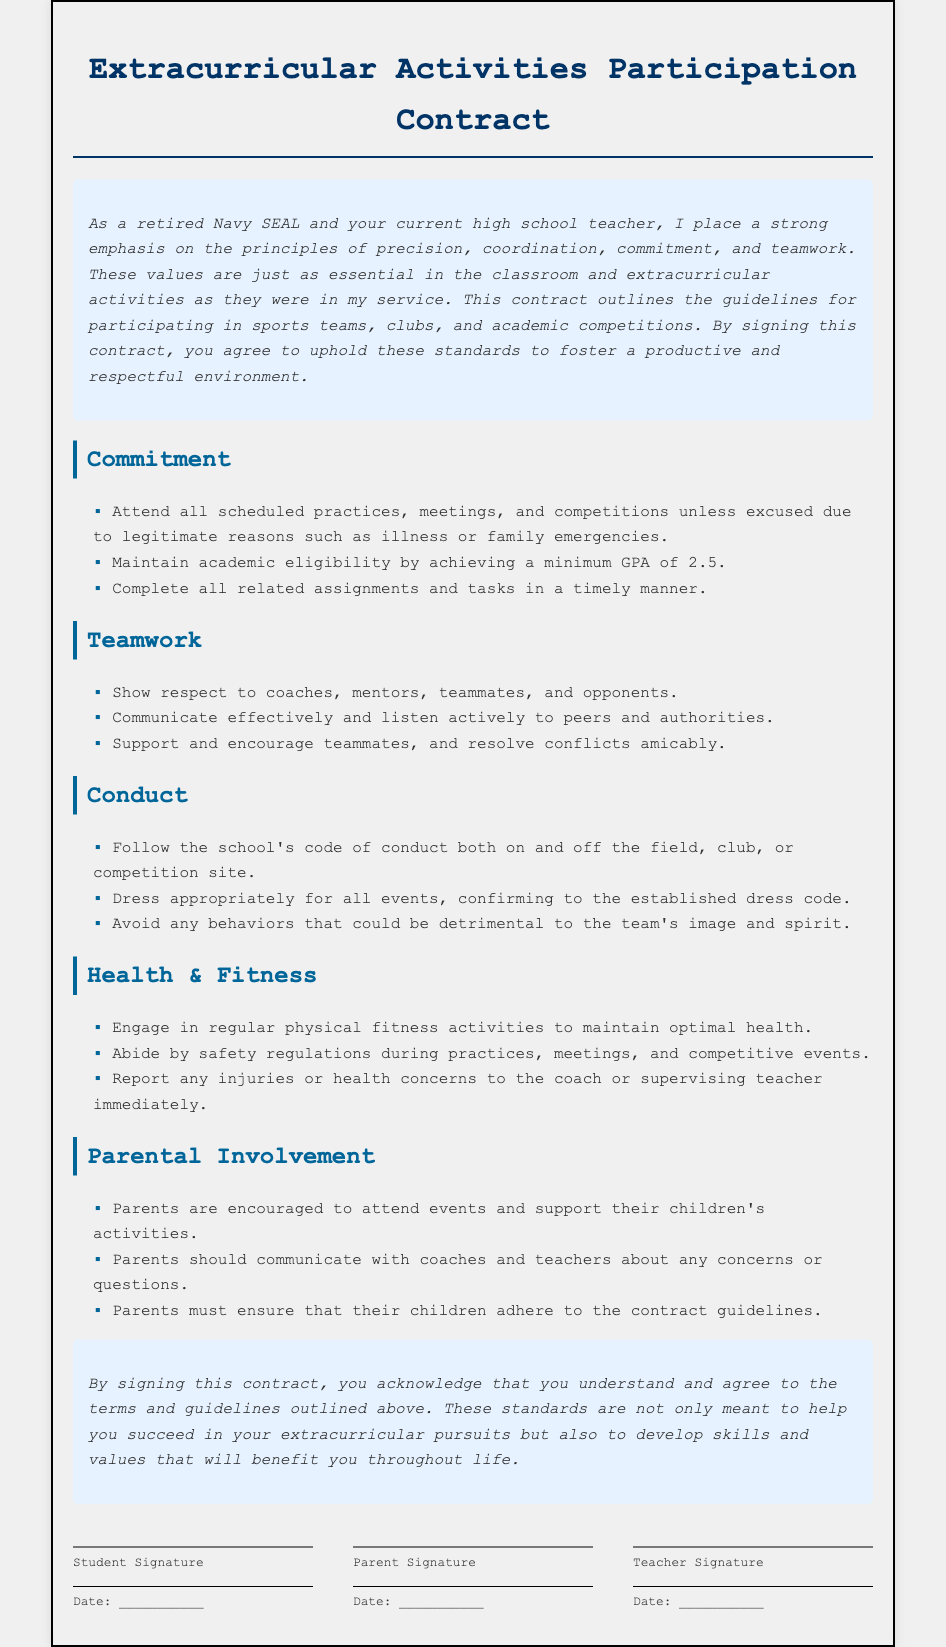What is the minimum GPA required for academic eligibility? The minimum GPA required is specified in the "Commitment" section of the document.
Answer: 2.5 What should students do if they have an injury? The document states that students should report any injuries to the coach or supervising teacher.
Answer: Report to coach or teacher Who is encouraged to attend events according to the contract? The "Parental Involvement" section encourages a specific group of people to attend events.
Answer: Parents What values are emphasized in the introduction of the document? The introduction outlines key principles expected of students in relation to their participation.
Answer: Precision, coordination, commitment, teamwork What does the conduct section advise regarding behavior? The "Conduct" section outlines acceptable behavior for students both on and off site.
Answer: Follow school's code of conduct What is the focus of the "Health & Fitness" section? This section addresses how students should maintain their physical health and safety during activities.
Answer: Regular physical fitness activities What is required regarding dress code during events? The "Conduct" section specifies a guideline related to appearance at events.
Answer: Dress appropriately Who must ensure that children adhere to the contract guidelines? The document specifies a responsibility that falls on a particular group of people.
Answer: Parents 